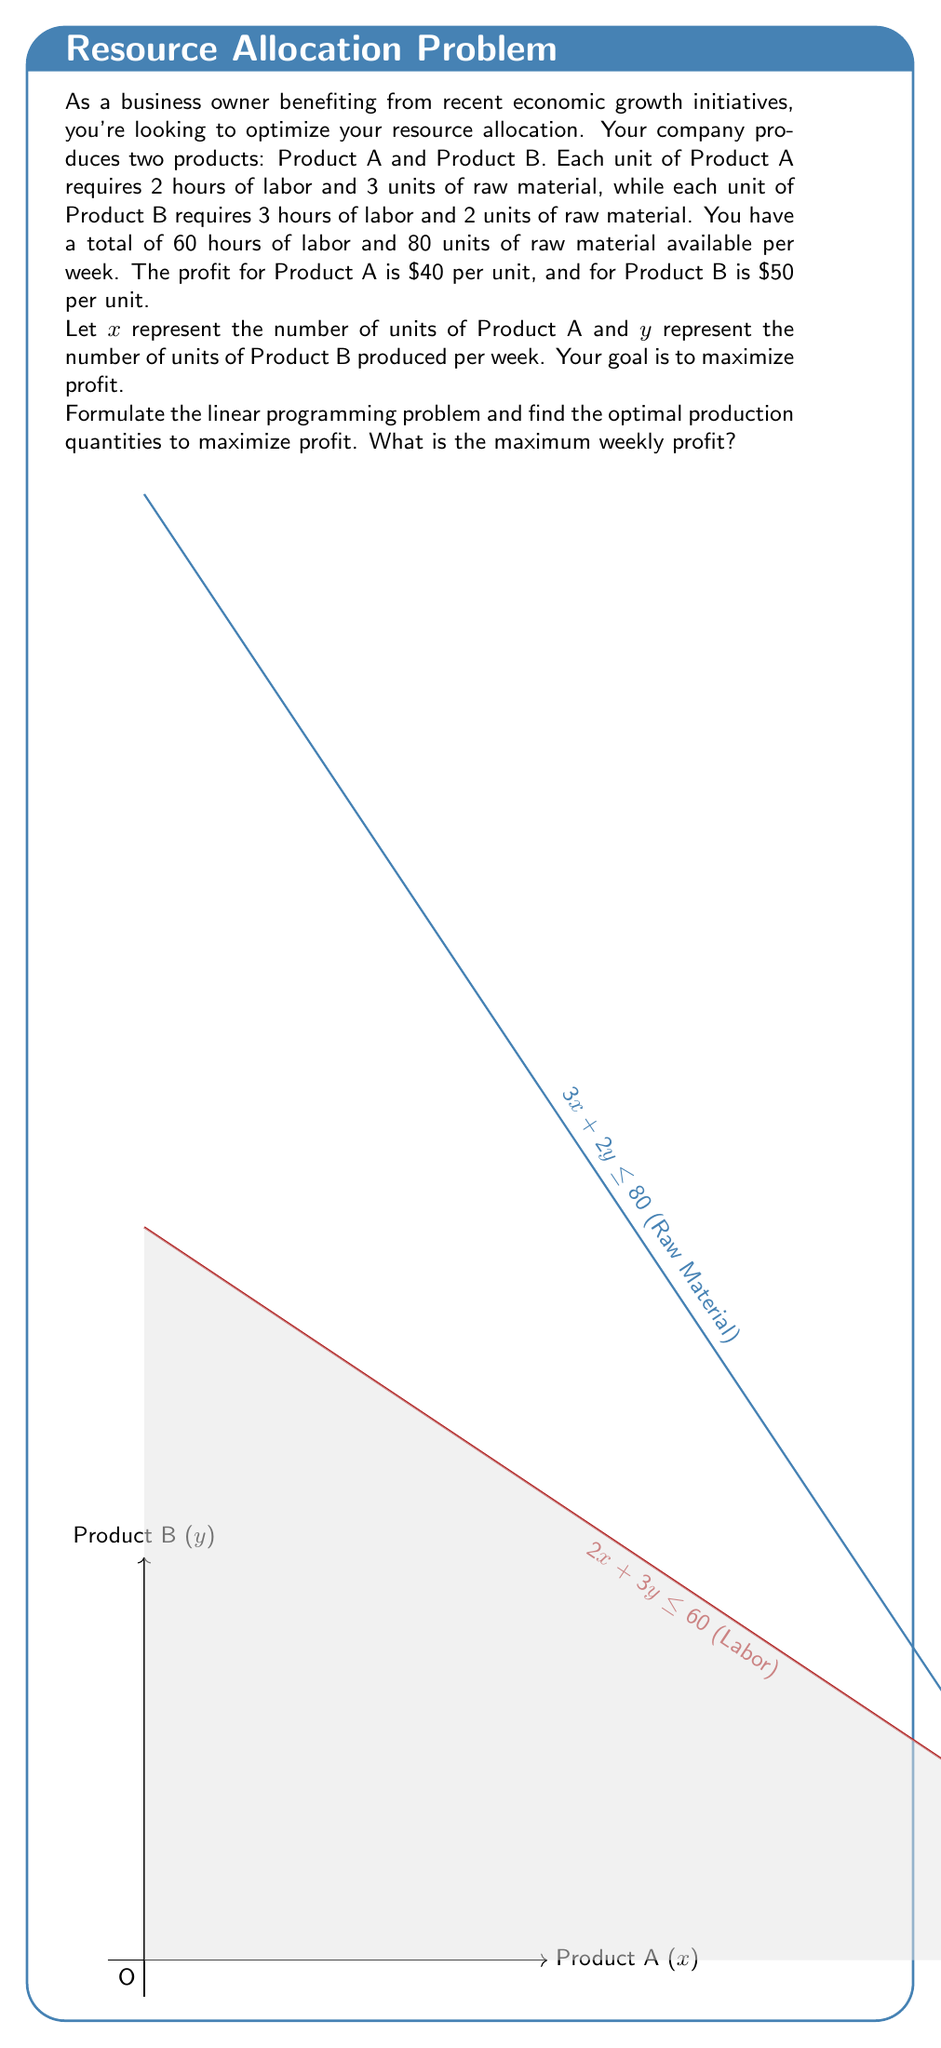Teach me how to tackle this problem. Let's approach this step-by-step:

1) First, we need to formulate the linear programming problem:

   Maximize: $Z = 40x + 50y$ (Profit function)
   
   Subject to:
   $2x + 3y \leq 60$ (Labor constraint)
   $3x + 2y \leq 80$ (Raw material constraint)
   $x \geq 0, y \geq 0$ (Non-negativity constraints)

2) We can solve this graphically. The feasible region is bounded by the constraints and the non-negativity conditions.

3) The optimal solution will be at one of the corner points of the feasible region. These points are:
   (0,0), (0,20), (24,4), (26.67,0)

4) Let's evaluate the profit function at each point:
   At (0,0): $Z = 40(0) + 50(0) = 0$
   At (0,20): $Z = 40(0) + 50(20) = 1000$
   At (24,4): $Z = 40(24) + 50(4) = 1160$
   At (26.67,0): $Z = 40(26.67) + 50(0) = 1066.8$

5) The maximum profit occurs at the point (24,4).

6) Therefore, the optimal production plan is to produce 24 units of Product A and 4 units of Product B per week.

7) The maximum weekly profit is:
   $Z = 40(24) + 50(4) = 960 + 200 = 1160$

Thus, the maximum weekly profit is $1160.
Answer: $1160 